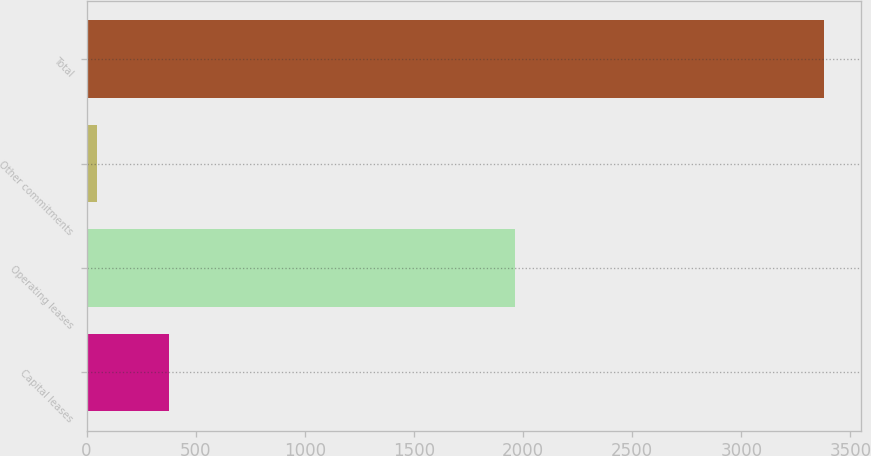Convert chart. <chart><loc_0><loc_0><loc_500><loc_500><bar_chart><fcel>Capital leases<fcel>Operating leases<fcel>Other commitments<fcel>Total<nl><fcel>379.5<fcel>1962.5<fcel>46.1<fcel>3380.1<nl></chart> 